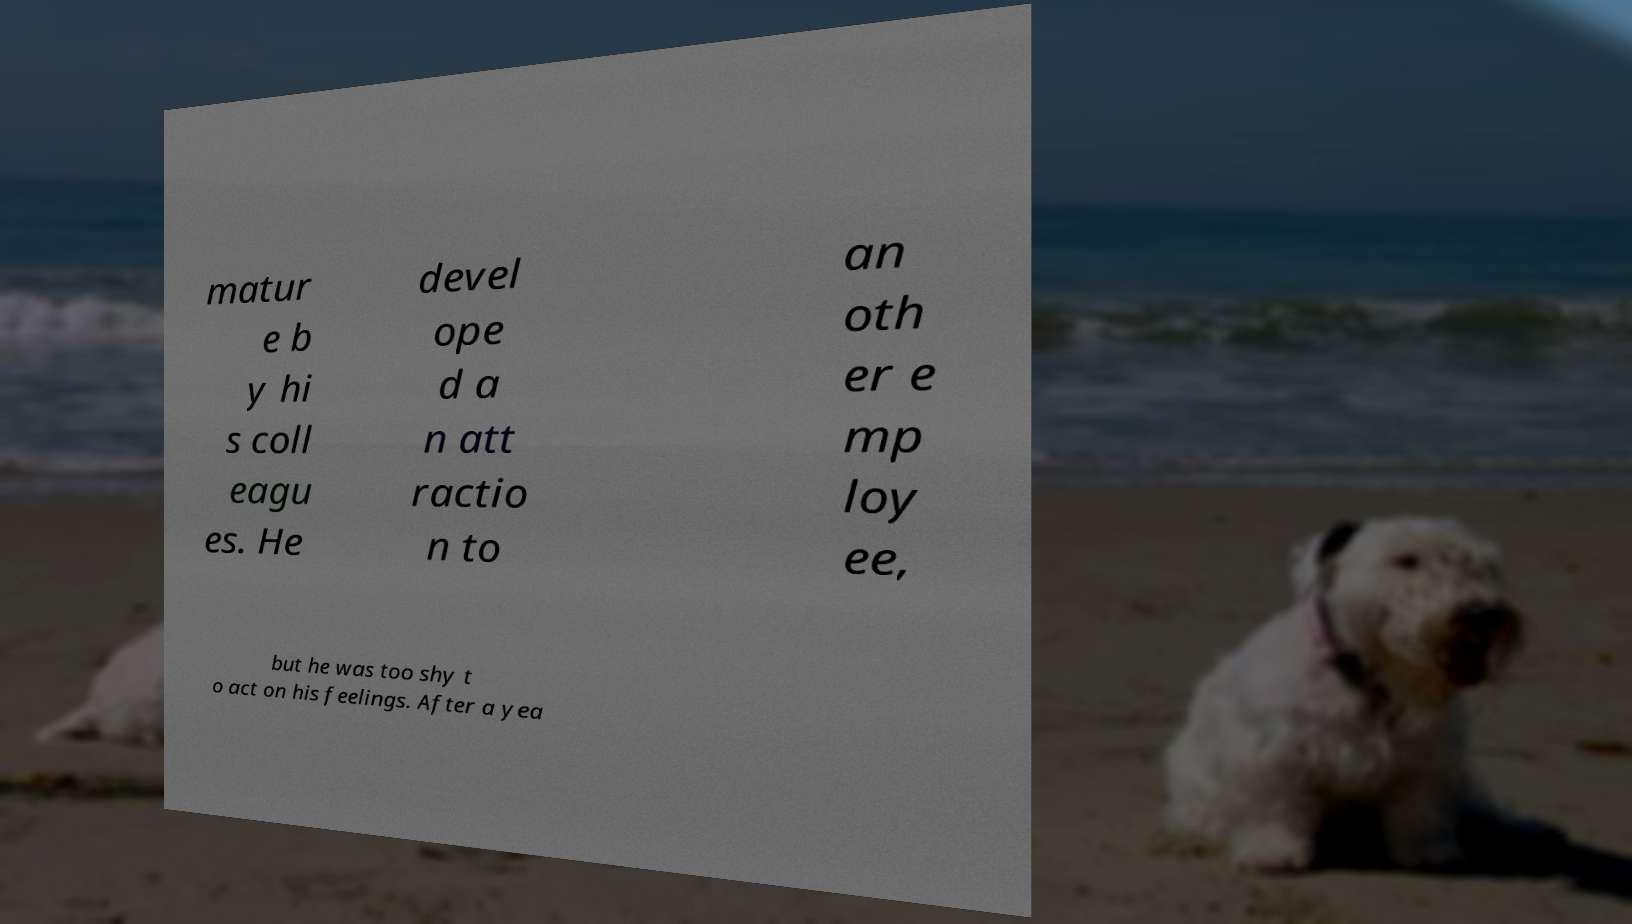Could you assist in decoding the text presented in this image and type it out clearly? matur e b y hi s coll eagu es. He devel ope d a n att ractio n to an oth er e mp loy ee, but he was too shy t o act on his feelings. After a yea 